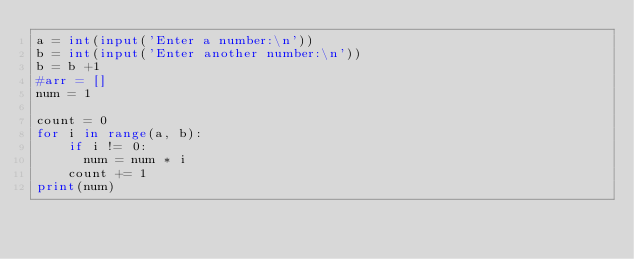Convert code to text. <code><loc_0><loc_0><loc_500><loc_500><_Python_>a = int(input('Enter a number:\n'))
b = int(input('Enter another number:\n'))
b = b +1
#arr = []
num = 1

count = 0
for i in range(a, b):
    if i != 0: 
      num = num * i
    count += 1
print(num)    
</code> 